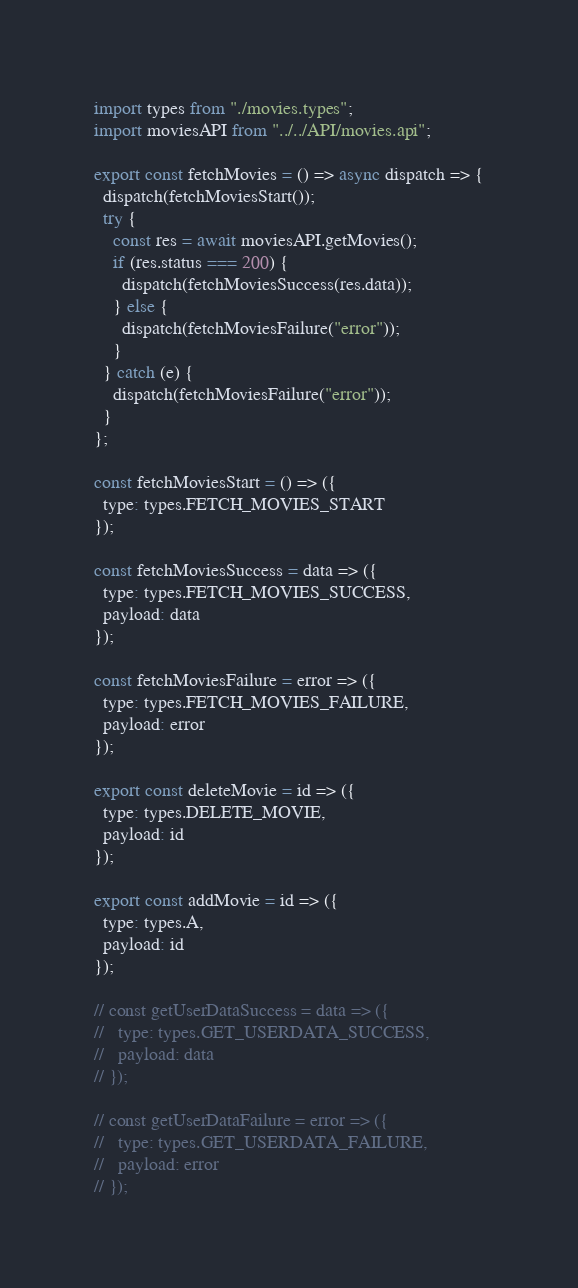Convert code to text. <code><loc_0><loc_0><loc_500><loc_500><_JavaScript_>import types from "./movies.types";
import moviesAPI from "../../API/movies.api";

export const fetchMovies = () => async dispatch => {
  dispatch(fetchMoviesStart());
  try {
    const res = await moviesAPI.getMovies();
    if (res.status === 200) {
      dispatch(fetchMoviesSuccess(res.data));
    } else {
      dispatch(fetchMoviesFailure("error"));
    }
  } catch (e) {
    dispatch(fetchMoviesFailure("error"));
  }
};

const fetchMoviesStart = () => ({
  type: types.FETCH_MOVIES_START
});

const fetchMoviesSuccess = data => ({
  type: types.FETCH_MOVIES_SUCCESS,
  payload: data
});

const fetchMoviesFailure = error => ({
  type: types.FETCH_MOVIES_FAILURE,
  payload: error
});

export const deleteMovie = id => ({
  type: types.DELETE_MOVIE,
  payload: id
});

export const addMovie = id => ({
  type: types.A,
  payload: id
});

// const getUserDataSuccess = data => ({
//   type: types.GET_USERDATA_SUCCESS,
//   payload: data
// });

// const getUserDataFailure = error => ({
//   type: types.GET_USERDATA_FAILURE,
//   payload: error
// });
</code> 